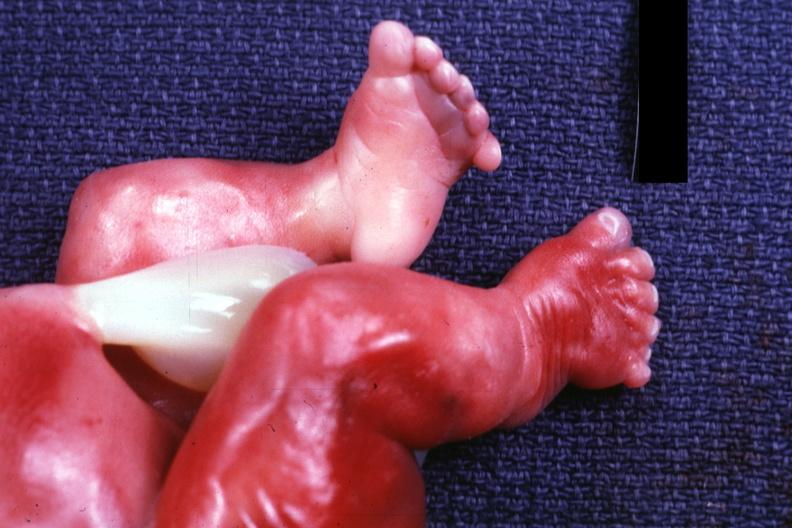how many digits is present?
Answer the question using a single word or phrase. Six 